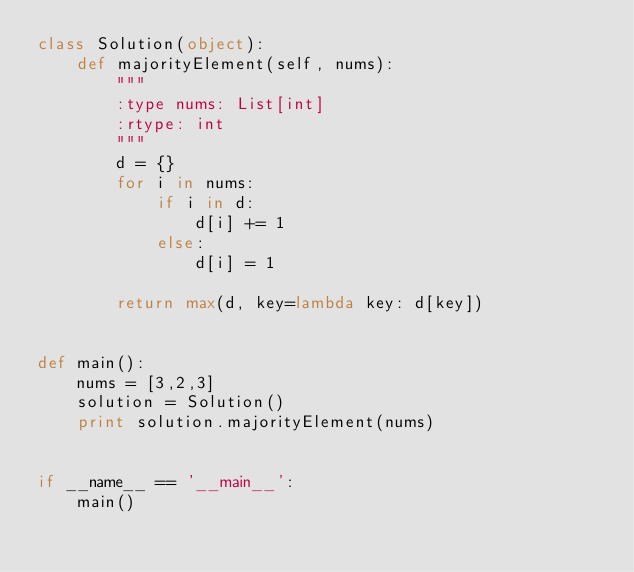<code> <loc_0><loc_0><loc_500><loc_500><_Python_>class Solution(object):
    def majorityElement(self, nums):
        """
        :type nums: List[int]
        :rtype: int
        """
        d = {}
        for i in nums:
            if i in d:
                d[i] += 1
            else:
                d[i] = 1

        return max(d, key=lambda key: d[key])


def main():
    nums = [3,2,3]
    solution = Solution()
    print solution.majorityElement(nums)


if __name__ == '__main__':
    main()</code> 